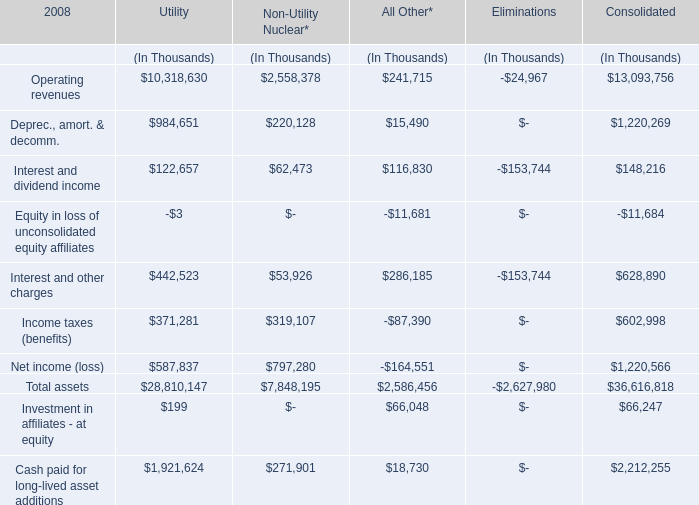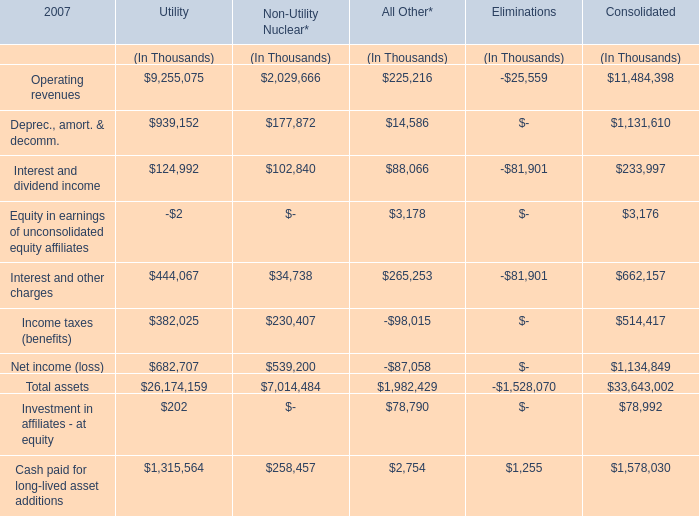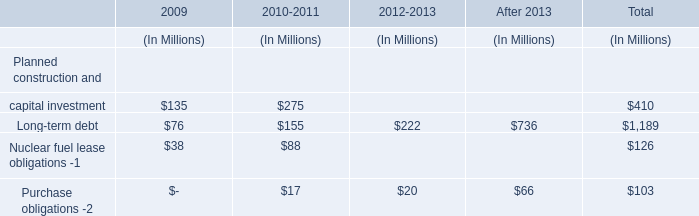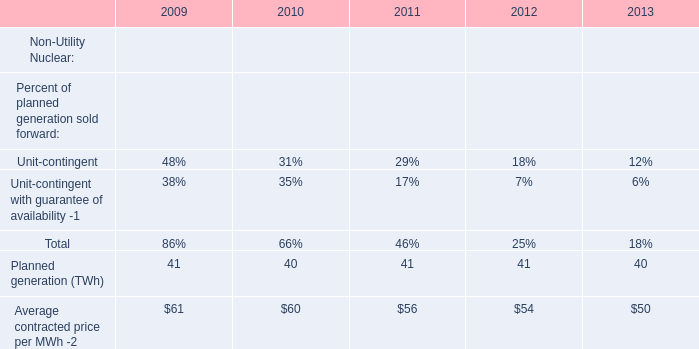What is the ratio of Utility's Operating revenues to the total in 2007? 
Computations: (9255075 / ((((9255075 + 2029666) + 225216) + -25559) + 11484398))
Answer: 0.40294. 